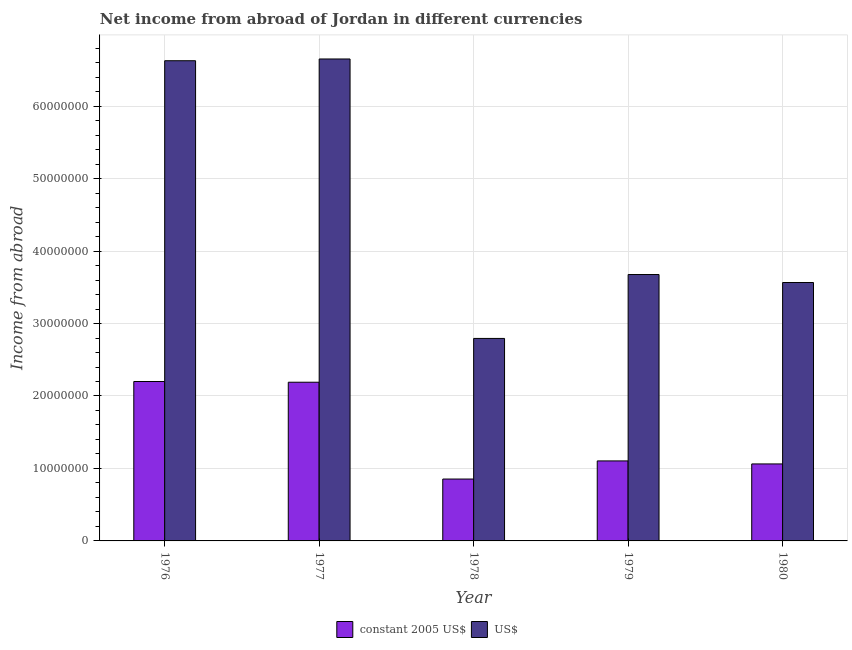How many different coloured bars are there?
Give a very brief answer. 2. Are the number of bars on each tick of the X-axis equal?
Offer a very short reply. Yes. What is the label of the 1st group of bars from the left?
Keep it short and to the point. 1976. What is the income from abroad in us$ in 1976?
Make the answer very short. 6.63e+07. Across all years, what is the maximum income from abroad in us$?
Offer a terse response. 6.65e+07. Across all years, what is the minimum income from abroad in us$?
Your answer should be very brief. 2.79e+07. In which year was the income from abroad in constant 2005 us$ maximum?
Make the answer very short. 1976. In which year was the income from abroad in constant 2005 us$ minimum?
Your answer should be very brief. 1978. What is the total income from abroad in constant 2005 us$ in the graph?
Make the answer very short. 7.41e+07. What is the difference between the income from abroad in us$ in 1976 and that in 1978?
Your answer should be compact. 3.83e+07. What is the difference between the income from abroad in us$ in 1979 and the income from abroad in constant 2005 us$ in 1977?
Your response must be concise. -2.97e+07. What is the average income from abroad in us$ per year?
Your answer should be compact. 4.66e+07. In how many years, is the income from abroad in constant 2005 us$ greater than 16000000 units?
Offer a very short reply. 2. What is the ratio of the income from abroad in constant 2005 us$ in 1976 to that in 1980?
Give a very brief answer. 2.07. Is the difference between the income from abroad in constant 2005 us$ in 1977 and 1978 greater than the difference between the income from abroad in us$ in 1977 and 1978?
Your response must be concise. No. What is the difference between the highest and the second highest income from abroad in us$?
Provide a short and direct response. 2.43e+05. What is the difference between the highest and the lowest income from abroad in constant 2005 us$?
Your answer should be compact. 1.35e+07. In how many years, is the income from abroad in constant 2005 us$ greater than the average income from abroad in constant 2005 us$ taken over all years?
Provide a short and direct response. 2. Is the sum of the income from abroad in us$ in 1976 and 1977 greater than the maximum income from abroad in constant 2005 us$ across all years?
Your response must be concise. Yes. What does the 1st bar from the left in 1980 represents?
Provide a succinct answer. Constant 2005 us$. What does the 2nd bar from the right in 1976 represents?
Ensure brevity in your answer.  Constant 2005 us$. How many bars are there?
Provide a short and direct response. 10. Are all the bars in the graph horizontal?
Give a very brief answer. No. What is the difference between two consecutive major ticks on the Y-axis?
Ensure brevity in your answer.  1.00e+07. Are the values on the major ticks of Y-axis written in scientific E-notation?
Provide a succinct answer. No. Does the graph contain any zero values?
Your answer should be very brief. No. How many legend labels are there?
Offer a terse response. 2. What is the title of the graph?
Offer a very short reply. Net income from abroad of Jordan in different currencies. Does "Age 65(female)" appear as one of the legend labels in the graph?
Make the answer very short. No. What is the label or title of the Y-axis?
Your answer should be very brief. Income from abroad. What is the Income from abroad of constant 2005 US$ in 1976?
Your answer should be very brief. 2.20e+07. What is the Income from abroad in US$ in 1976?
Provide a succinct answer. 6.63e+07. What is the Income from abroad in constant 2005 US$ in 1977?
Your answer should be very brief. 2.19e+07. What is the Income from abroad of US$ in 1977?
Offer a very short reply. 6.65e+07. What is the Income from abroad in constant 2005 US$ in 1978?
Give a very brief answer. 8.54e+06. What is the Income from abroad of US$ in 1978?
Your response must be concise. 2.79e+07. What is the Income from abroad of constant 2005 US$ in 1979?
Keep it short and to the point. 1.10e+07. What is the Income from abroad in US$ in 1979?
Ensure brevity in your answer.  3.68e+07. What is the Income from abroad of constant 2005 US$ in 1980?
Make the answer very short. 1.06e+07. What is the Income from abroad of US$ in 1980?
Offer a terse response. 3.57e+07. Across all years, what is the maximum Income from abroad of constant 2005 US$?
Your answer should be very brief. 2.20e+07. Across all years, what is the maximum Income from abroad of US$?
Offer a very short reply. 6.65e+07. Across all years, what is the minimum Income from abroad in constant 2005 US$?
Offer a very short reply. 8.54e+06. Across all years, what is the minimum Income from abroad in US$?
Provide a succinct answer. 2.79e+07. What is the total Income from abroad of constant 2005 US$ in the graph?
Offer a terse response. 7.41e+07. What is the total Income from abroad of US$ in the graph?
Keep it short and to the point. 2.33e+08. What is the difference between the Income from abroad of US$ in 1976 and that in 1977?
Keep it short and to the point. -2.43e+05. What is the difference between the Income from abroad of constant 2005 US$ in 1976 and that in 1978?
Offer a terse response. 1.35e+07. What is the difference between the Income from abroad in US$ in 1976 and that in 1978?
Offer a terse response. 3.83e+07. What is the difference between the Income from abroad in constant 2005 US$ in 1976 and that in 1979?
Give a very brief answer. 1.10e+07. What is the difference between the Income from abroad of US$ in 1976 and that in 1979?
Your response must be concise. 2.95e+07. What is the difference between the Income from abroad in constant 2005 US$ in 1976 and that in 1980?
Keep it short and to the point. 1.14e+07. What is the difference between the Income from abroad in US$ in 1976 and that in 1980?
Provide a short and direct response. 3.06e+07. What is the difference between the Income from abroad in constant 2005 US$ in 1977 and that in 1978?
Offer a very short reply. 1.34e+07. What is the difference between the Income from abroad in US$ in 1977 and that in 1978?
Keep it short and to the point. 3.86e+07. What is the difference between the Income from abroad of constant 2005 US$ in 1977 and that in 1979?
Keep it short and to the point. 1.09e+07. What is the difference between the Income from abroad in US$ in 1977 and that in 1979?
Your answer should be very brief. 2.97e+07. What is the difference between the Income from abroad of constant 2005 US$ in 1977 and that in 1980?
Your response must be concise. 1.13e+07. What is the difference between the Income from abroad in US$ in 1977 and that in 1980?
Make the answer very short. 3.08e+07. What is the difference between the Income from abroad of constant 2005 US$ in 1978 and that in 1979?
Offer a terse response. -2.50e+06. What is the difference between the Income from abroad in US$ in 1978 and that in 1979?
Give a very brief answer. -8.82e+06. What is the difference between the Income from abroad of constant 2005 US$ in 1978 and that in 1980?
Make the answer very short. -2.08e+06. What is the difference between the Income from abroad of US$ in 1978 and that in 1980?
Provide a succinct answer. -7.72e+06. What is the difference between the Income from abroad of constant 2005 US$ in 1979 and that in 1980?
Your response must be concise. 4.16e+05. What is the difference between the Income from abroad of US$ in 1979 and that in 1980?
Ensure brevity in your answer.  1.10e+06. What is the difference between the Income from abroad of constant 2005 US$ in 1976 and the Income from abroad of US$ in 1977?
Offer a very short reply. -4.45e+07. What is the difference between the Income from abroad of constant 2005 US$ in 1976 and the Income from abroad of US$ in 1978?
Offer a very short reply. -5.95e+06. What is the difference between the Income from abroad of constant 2005 US$ in 1976 and the Income from abroad of US$ in 1979?
Your answer should be very brief. -1.48e+07. What is the difference between the Income from abroad in constant 2005 US$ in 1976 and the Income from abroad in US$ in 1980?
Your answer should be very brief. -1.37e+07. What is the difference between the Income from abroad of constant 2005 US$ in 1977 and the Income from abroad of US$ in 1978?
Keep it short and to the point. -6.05e+06. What is the difference between the Income from abroad in constant 2005 US$ in 1977 and the Income from abroad in US$ in 1979?
Make the answer very short. -1.49e+07. What is the difference between the Income from abroad in constant 2005 US$ in 1977 and the Income from abroad in US$ in 1980?
Keep it short and to the point. -1.38e+07. What is the difference between the Income from abroad in constant 2005 US$ in 1978 and the Income from abroad in US$ in 1979?
Your answer should be very brief. -2.82e+07. What is the difference between the Income from abroad in constant 2005 US$ in 1978 and the Income from abroad in US$ in 1980?
Provide a succinct answer. -2.71e+07. What is the difference between the Income from abroad in constant 2005 US$ in 1979 and the Income from abroad in US$ in 1980?
Provide a short and direct response. -2.46e+07. What is the average Income from abroad in constant 2005 US$ per year?
Ensure brevity in your answer.  1.48e+07. What is the average Income from abroad of US$ per year?
Your response must be concise. 4.66e+07. In the year 1976, what is the difference between the Income from abroad in constant 2005 US$ and Income from abroad in US$?
Offer a terse response. -4.43e+07. In the year 1977, what is the difference between the Income from abroad of constant 2005 US$ and Income from abroad of US$?
Ensure brevity in your answer.  -4.46e+07. In the year 1978, what is the difference between the Income from abroad of constant 2005 US$ and Income from abroad of US$?
Your answer should be very brief. -1.94e+07. In the year 1979, what is the difference between the Income from abroad in constant 2005 US$ and Income from abroad in US$?
Your response must be concise. -2.57e+07. In the year 1980, what is the difference between the Income from abroad of constant 2005 US$ and Income from abroad of US$?
Offer a terse response. -2.50e+07. What is the ratio of the Income from abroad of constant 2005 US$ in 1976 to that in 1977?
Your answer should be compact. 1. What is the ratio of the Income from abroad of constant 2005 US$ in 1976 to that in 1978?
Provide a succinct answer. 2.58. What is the ratio of the Income from abroad of US$ in 1976 to that in 1978?
Ensure brevity in your answer.  2.37. What is the ratio of the Income from abroad of constant 2005 US$ in 1976 to that in 1979?
Ensure brevity in your answer.  1.99. What is the ratio of the Income from abroad of US$ in 1976 to that in 1979?
Keep it short and to the point. 1.8. What is the ratio of the Income from abroad of constant 2005 US$ in 1976 to that in 1980?
Provide a short and direct response. 2.07. What is the ratio of the Income from abroad of US$ in 1976 to that in 1980?
Offer a very short reply. 1.86. What is the ratio of the Income from abroad of constant 2005 US$ in 1977 to that in 1978?
Your answer should be very brief. 2.56. What is the ratio of the Income from abroad in US$ in 1977 to that in 1978?
Ensure brevity in your answer.  2.38. What is the ratio of the Income from abroad of constant 2005 US$ in 1977 to that in 1979?
Provide a short and direct response. 1.98. What is the ratio of the Income from abroad in US$ in 1977 to that in 1979?
Your response must be concise. 1.81. What is the ratio of the Income from abroad in constant 2005 US$ in 1977 to that in 1980?
Offer a terse response. 2.06. What is the ratio of the Income from abroad of US$ in 1977 to that in 1980?
Offer a terse response. 1.86. What is the ratio of the Income from abroad of constant 2005 US$ in 1978 to that in 1979?
Your answer should be compact. 0.77. What is the ratio of the Income from abroad in US$ in 1978 to that in 1979?
Offer a very short reply. 0.76. What is the ratio of the Income from abroad in constant 2005 US$ in 1978 to that in 1980?
Make the answer very short. 0.8. What is the ratio of the Income from abroad in US$ in 1978 to that in 1980?
Provide a short and direct response. 0.78. What is the ratio of the Income from abroad in constant 2005 US$ in 1979 to that in 1980?
Offer a very short reply. 1.04. What is the ratio of the Income from abroad in US$ in 1979 to that in 1980?
Your response must be concise. 1.03. What is the difference between the highest and the second highest Income from abroad of US$?
Make the answer very short. 2.43e+05. What is the difference between the highest and the lowest Income from abroad of constant 2005 US$?
Ensure brevity in your answer.  1.35e+07. What is the difference between the highest and the lowest Income from abroad in US$?
Provide a succinct answer. 3.86e+07. 